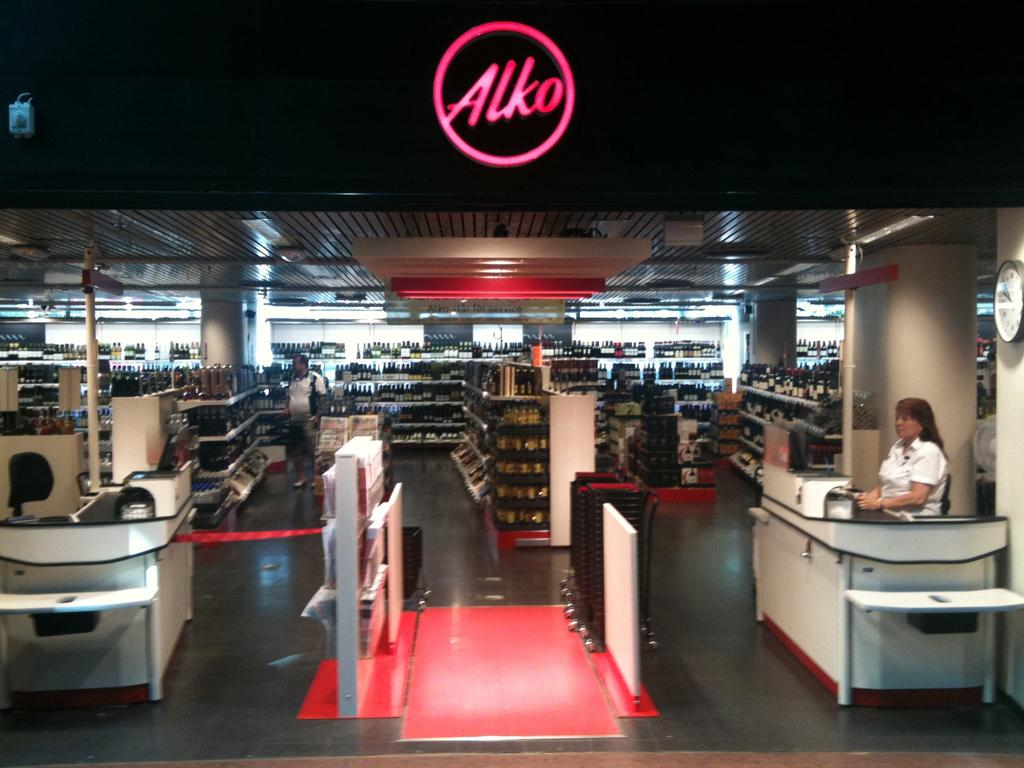<image>
Present a compact description of the photo's key features. The store Alko has many bottles of alcohol in it. 